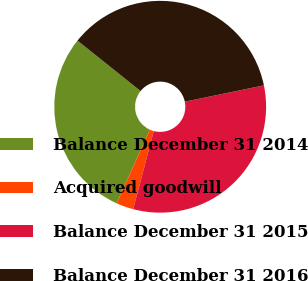Convert chart to OTSL. <chart><loc_0><loc_0><loc_500><loc_500><pie_chart><fcel>Balance December 31 2014<fcel>Acquired goodwill<fcel>Balance December 31 2015<fcel>Balance December 31 2016<nl><fcel>29.0%<fcel>2.63%<fcel>32.34%<fcel>36.03%<nl></chart> 